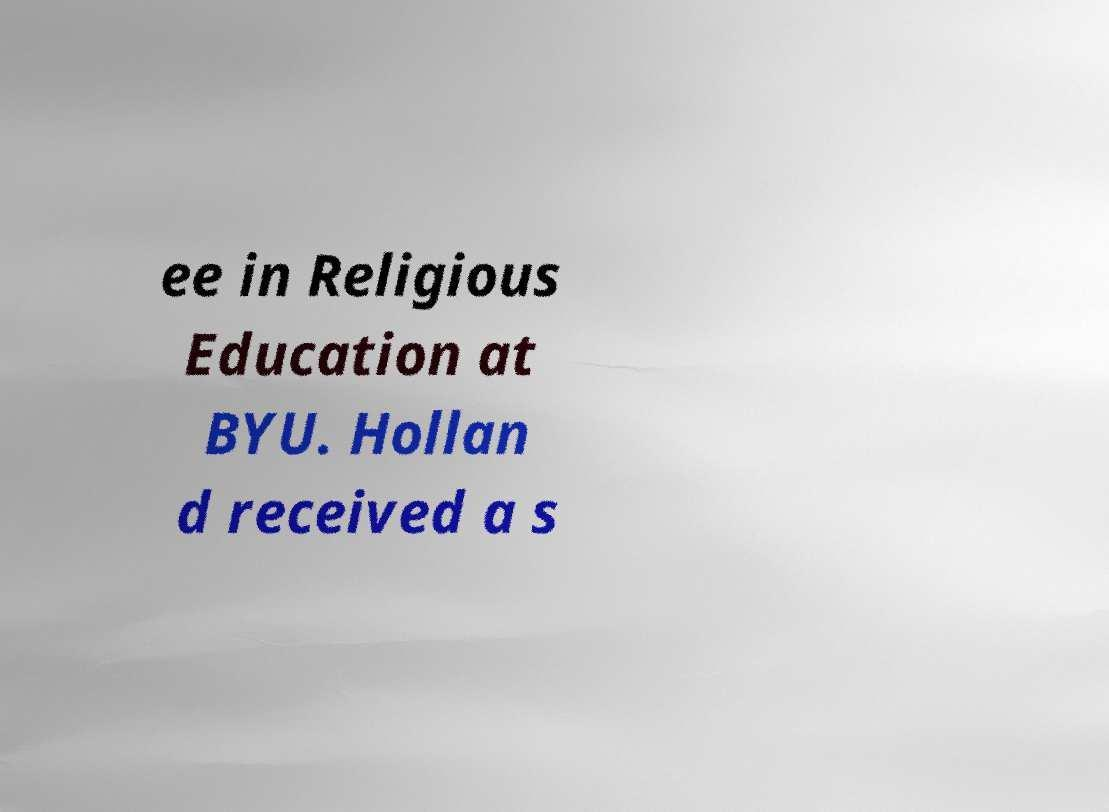For documentation purposes, I need the text within this image transcribed. Could you provide that? ee in Religious Education at BYU. Hollan d received a s 